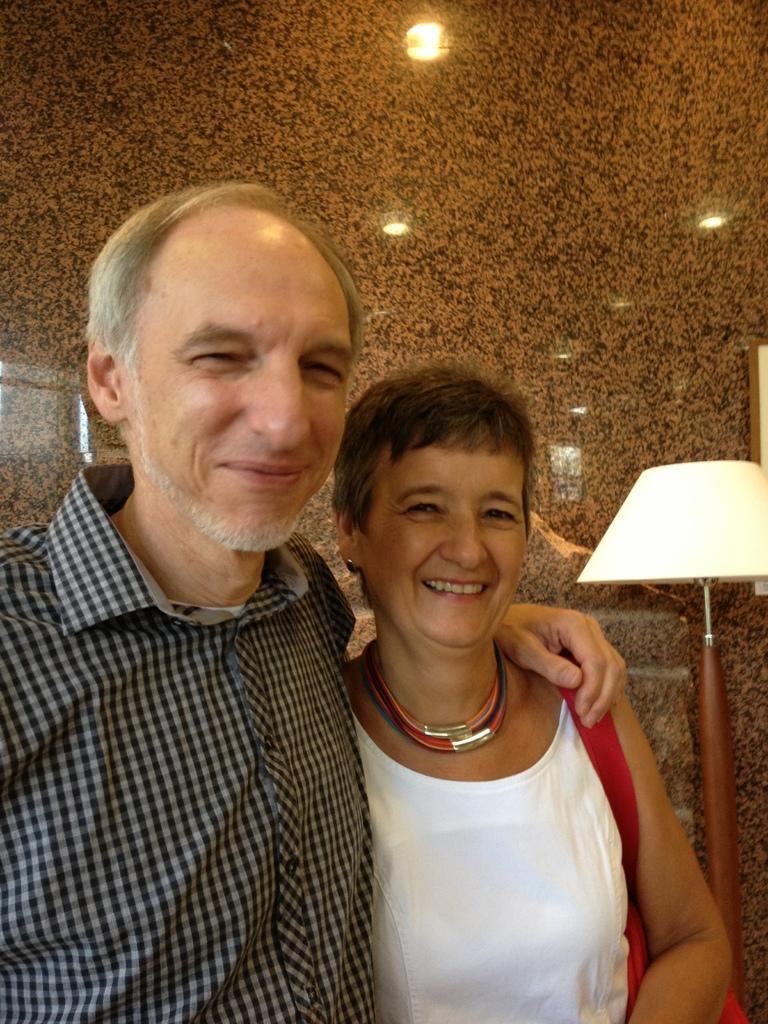In one or two sentences, can you explain what this image depicts? In this image there is a man standing, there is a woman standing, she is wearing a bag, there is a lamp, there is the wall, there are lights visible on the wall. 